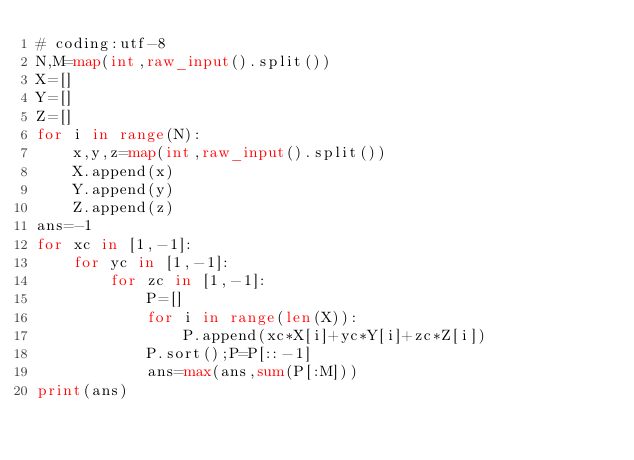<code> <loc_0><loc_0><loc_500><loc_500><_Python_># coding:utf-8
N,M=map(int,raw_input().split())
X=[]
Y=[]
Z=[]
for i in range(N):
    x,y,z=map(int,raw_input().split())
    X.append(x)
    Y.append(y)
    Z.append(z)
ans=-1
for xc in [1,-1]:
    for yc in [1,-1]:
        for zc in [1,-1]:
            P=[]
            for i in range(len(X)):
                P.append(xc*X[i]+yc*Y[i]+zc*Z[i])
            P.sort();P=P[::-1]
            ans=max(ans,sum(P[:M]))
print(ans)

</code> 